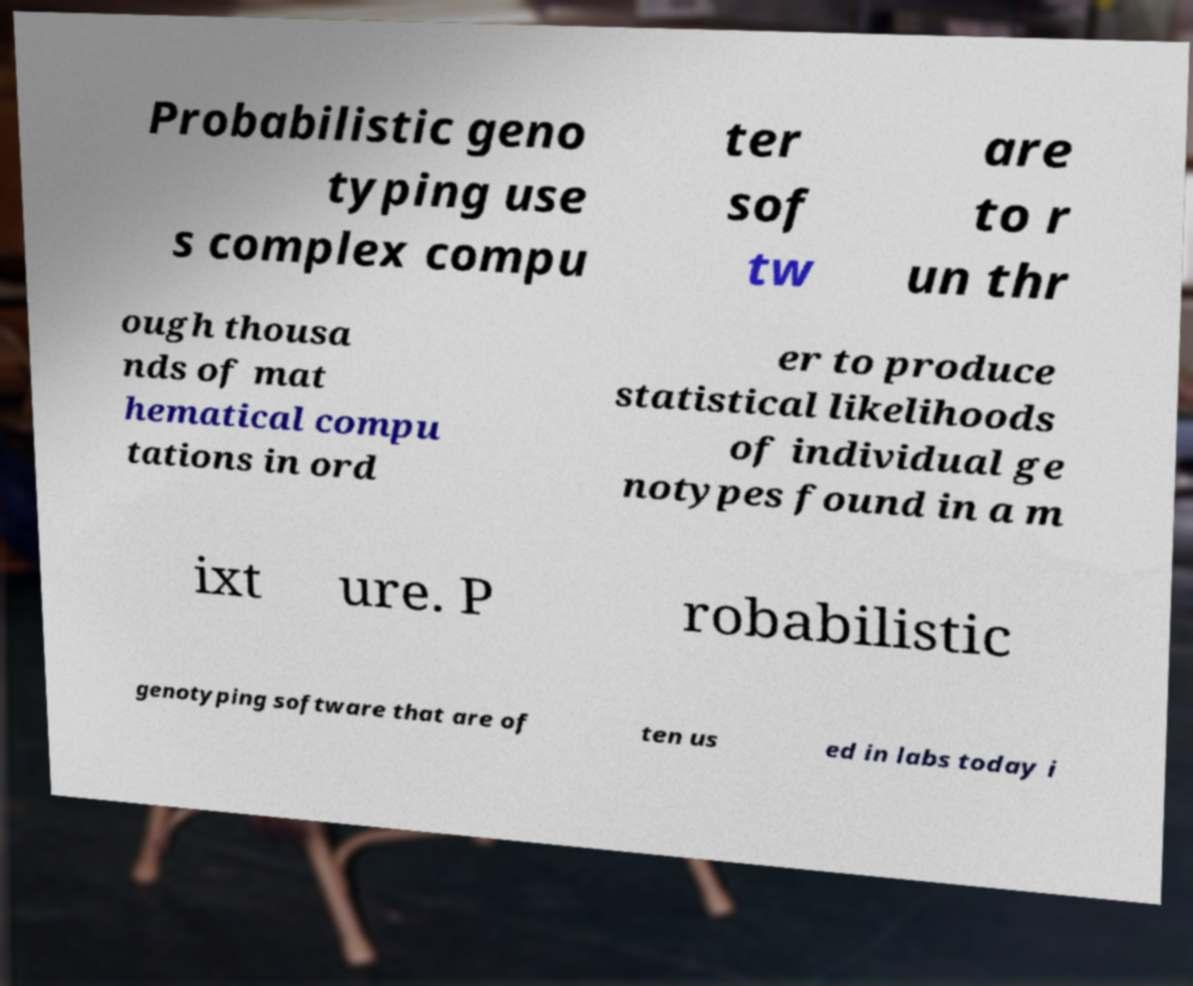What messages or text are displayed in this image? I need them in a readable, typed format. Probabilistic geno typing use s complex compu ter sof tw are to r un thr ough thousa nds of mat hematical compu tations in ord er to produce statistical likelihoods of individual ge notypes found in a m ixt ure. P robabilistic genotyping software that are of ten us ed in labs today i 